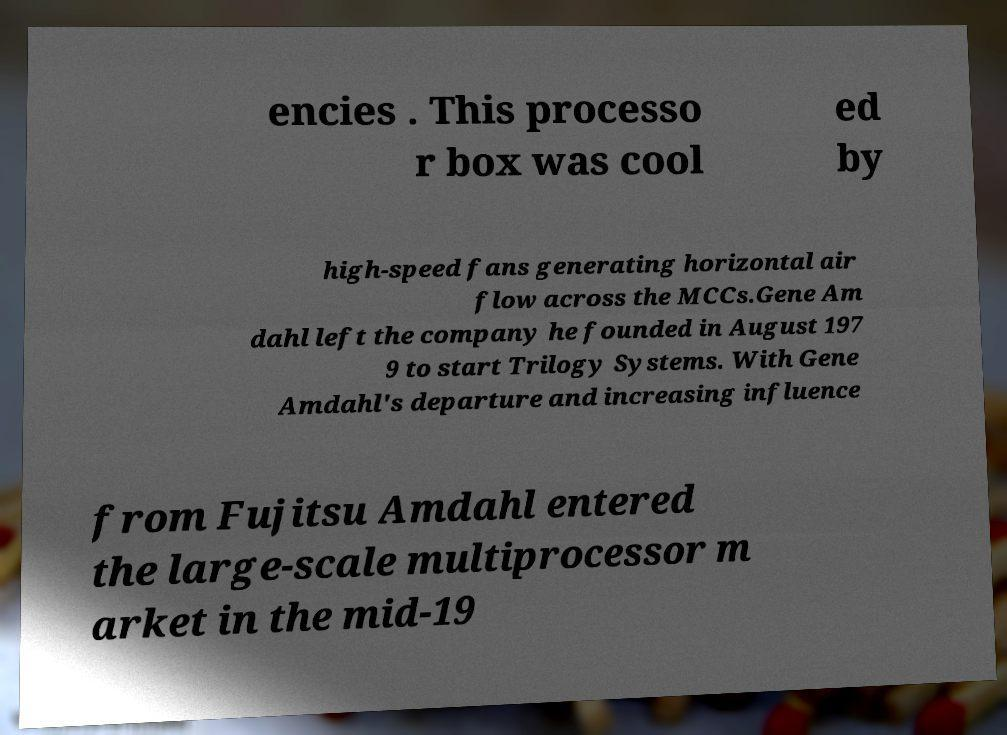Can you read and provide the text displayed in the image?This photo seems to have some interesting text. Can you extract and type it out for me? encies . This processo r box was cool ed by high-speed fans generating horizontal air flow across the MCCs.Gene Am dahl left the company he founded in August 197 9 to start Trilogy Systems. With Gene Amdahl's departure and increasing influence from Fujitsu Amdahl entered the large-scale multiprocessor m arket in the mid-19 